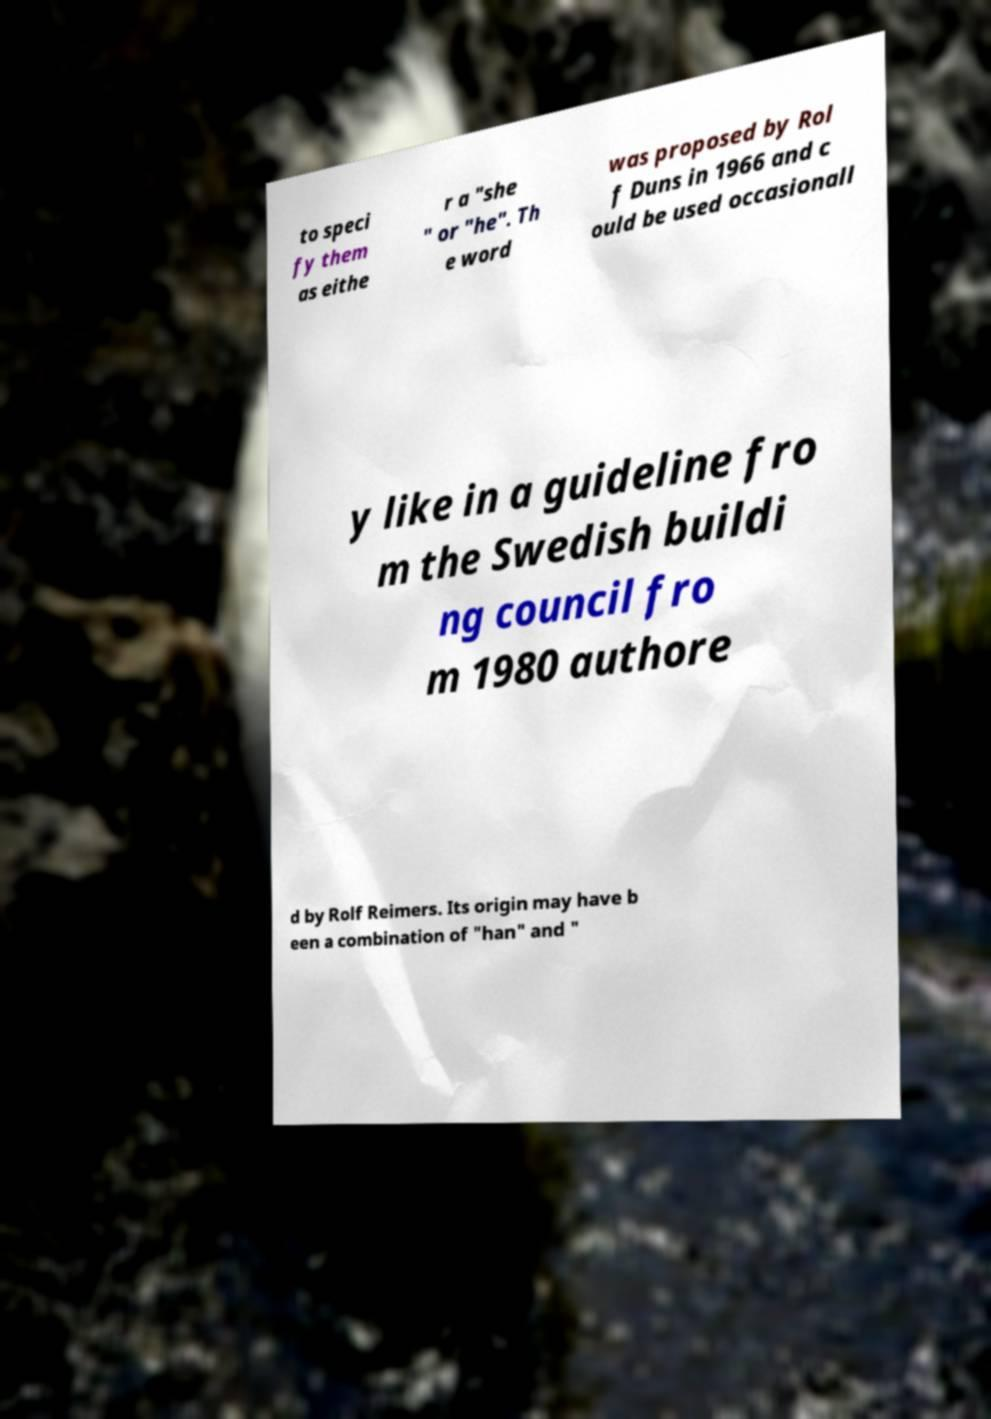Could you assist in decoding the text presented in this image and type it out clearly? to speci fy them as eithe r a "she " or "he". Th e word was proposed by Rol f Duns in 1966 and c ould be used occasionall y like in a guideline fro m the Swedish buildi ng council fro m 1980 authore d by Rolf Reimers. Its origin may have b een a combination of "han" and " 